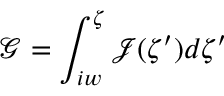<formula> <loc_0><loc_0><loc_500><loc_500>\mathcal { G } = \int _ { i w } ^ { \zeta } \mathcal { J } ( \zeta ^ { \prime } ) d \zeta ^ { \prime }</formula> 